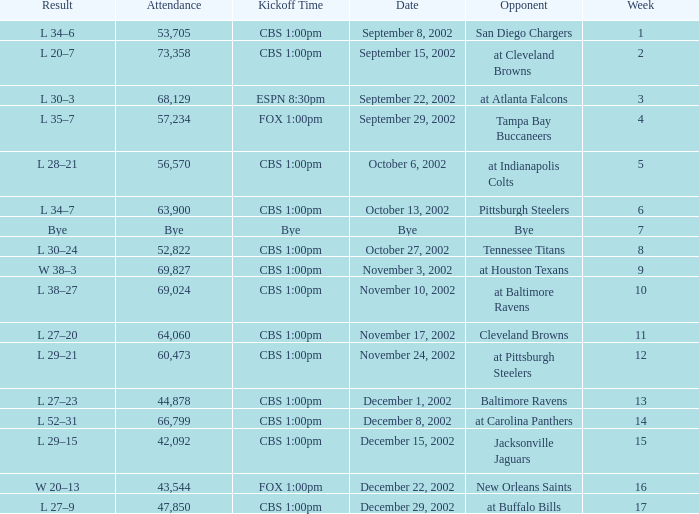What week was the opponent the San Diego Chargers? 1.0. 